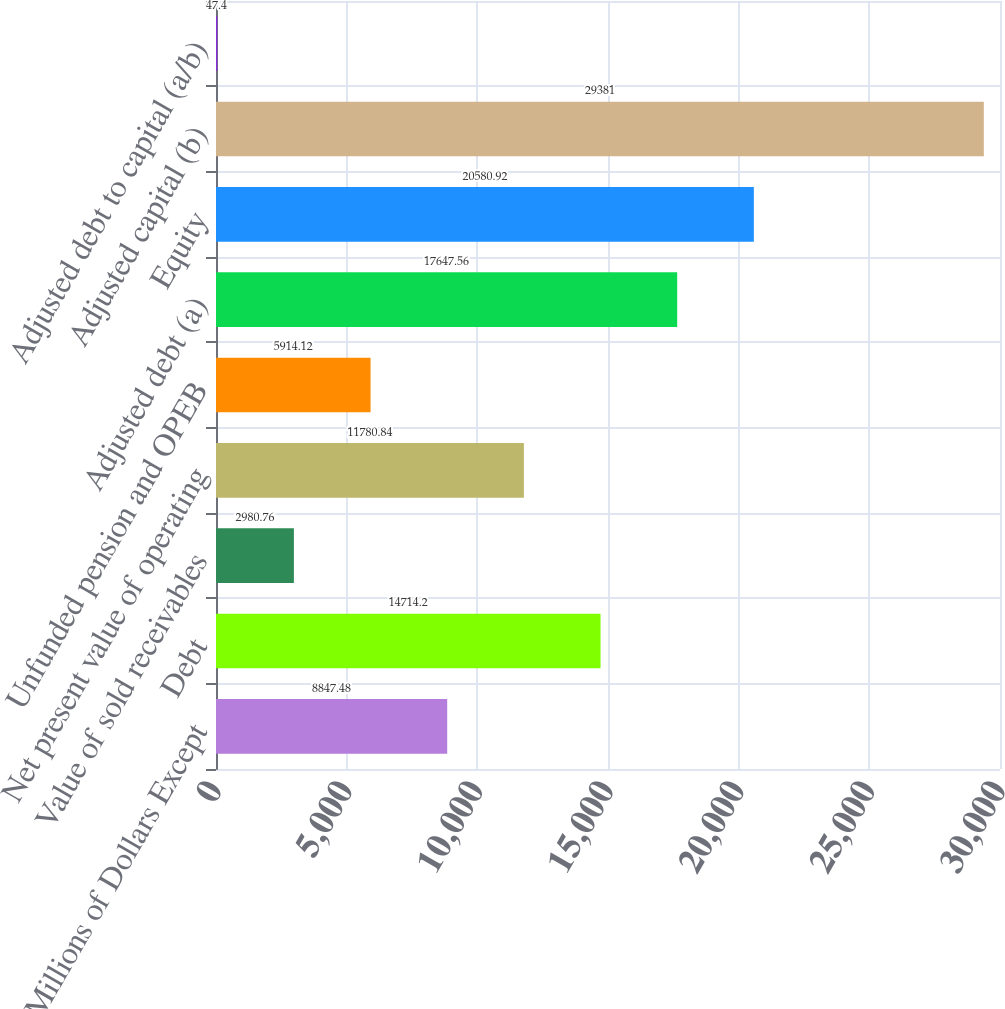Convert chart. <chart><loc_0><loc_0><loc_500><loc_500><bar_chart><fcel>Millions of Dollars Except<fcel>Debt<fcel>Value of sold receivables<fcel>Net present value of operating<fcel>Unfunded pension and OPEB<fcel>Adjusted debt (a)<fcel>Equity<fcel>Adjusted capital (b)<fcel>Adjusted debt to capital (a/b)<nl><fcel>8847.48<fcel>14714.2<fcel>2980.76<fcel>11780.8<fcel>5914.12<fcel>17647.6<fcel>20580.9<fcel>29381<fcel>47.4<nl></chart> 